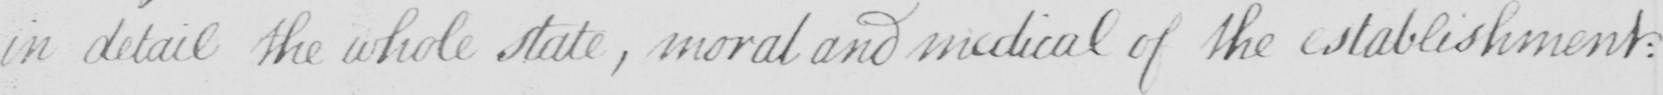Please provide the text content of this handwritten line. in detail the whole state  , moral and medical of the establishment : 